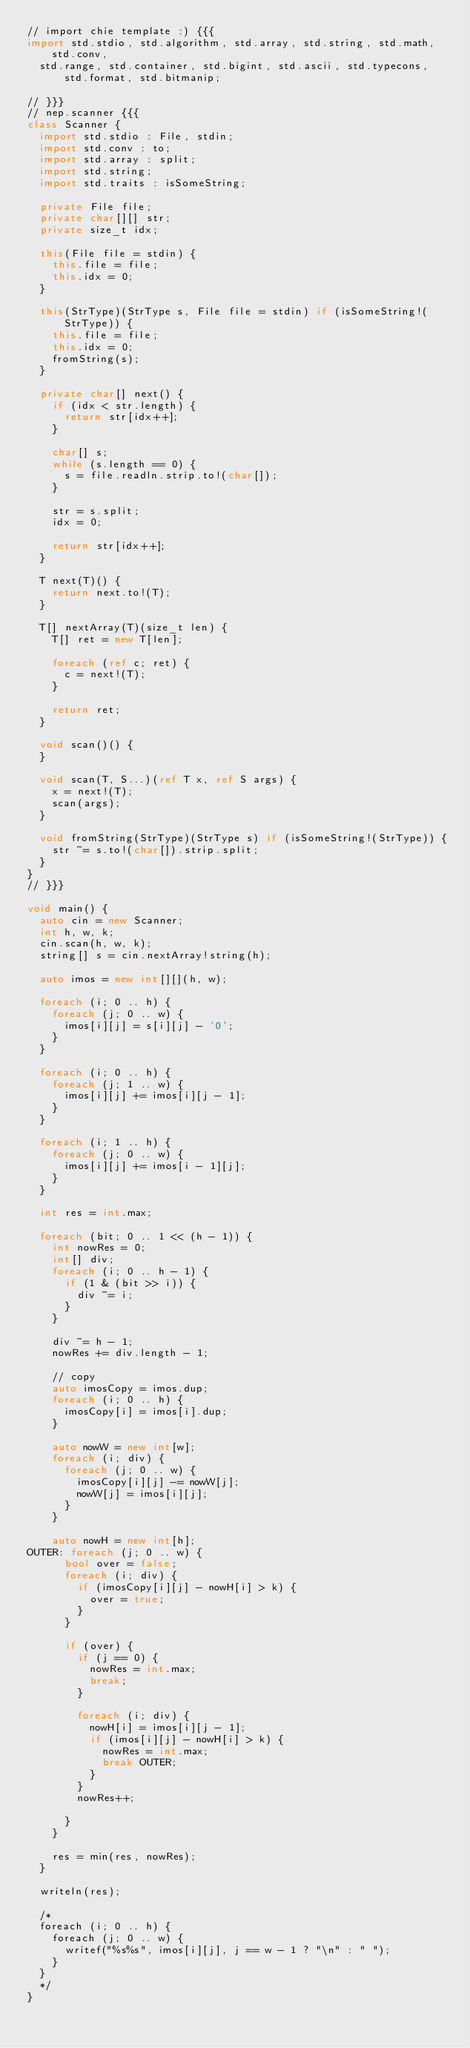<code> <loc_0><loc_0><loc_500><loc_500><_D_>// import chie template :) {{{
import std.stdio, std.algorithm, std.array, std.string, std.math, std.conv,
  std.range, std.container, std.bigint, std.ascii, std.typecons, std.format, std.bitmanip;

// }}}
// nep.scanner {{{
class Scanner {
  import std.stdio : File, stdin;
  import std.conv : to;
  import std.array : split;
  import std.string;
  import std.traits : isSomeString;

  private File file;
  private char[][] str;
  private size_t idx;

  this(File file = stdin) {
    this.file = file;
    this.idx = 0;
  }

  this(StrType)(StrType s, File file = stdin) if (isSomeString!(StrType)) {
    this.file = file;
    this.idx = 0;
    fromString(s);
  }

  private char[] next() {
    if (idx < str.length) {
      return str[idx++];
    }

    char[] s;
    while (s.length == 0) {
      s = file.readln.strip.to!(char[]);
    }

    str = s.split;
    idx = 0;

    return str[idx++];
  }

  T next(T)() {
    return next.to!(T);
  }

  T[] nextArray(T)(size_t len) {
    T[] ret = new T[len];

    foreach (ref c; ret) {
      c = next!(T);
    }

    return ret;
  }

  void scan()() {
  }

  void scan(T, S...)(ref T x, ref S args) {
    x = next!(T);
    scan(args);
  }

  void fromString(StrType)(StrType s) if (isSomeString!(StrType)) {
    str ~= s.to!(char[]).strip.split;
  }
}
// }}}

void main() {
  auto cin = new Scanner;
  int h, w, k;
  cin.scan(h, w, k);
  string[] s = cin.nextArray!string(h);

  auto imos = new int[][](h, w);

  foreach (i; 0 .. h) {
    foreach (j; 0 .. w) {
      imos[i][j] = s[i][j] - '0';
    }
  }

  foreach (i; 0 .. h) {
    foreach (j; 1 .. w) {
      imos[i][j] += imos[i][j - 1];
    }
  }

  foreach (i; 1 .. h) {
    foreach (j; 0 .. w) {
      imos[i][j] += imos[i - 1][j];
    }
  }

  int res = int.max;

  foreach (bit; 0 .. 1 << (h - 1)) {
    int nowRes = 0;
    int[] div;
    foreach (i; 0 .. h - 1) {
      if (1 & (bit >> i)) {
        div ~= i;
      }
    }

    div ~= h - 1;
    nowRes += div.length - 1;

    // copy
    auto imosCopy = imos.dup;
    foreach (i; 0 .. h) {
      imosCopy[i] = imos[i].dup;
    }

    auto nowW = new int[w];
    foreach (i; div) {
      foreach (j; 0 .. w) {
        imosCopy[i][j] -= nowW[j];
        nowW[j] = imos[i][j];
      }
    }

    auto nowH = new int[h];
OUTER: foreach (j; 0 .. w) {
      bool over = false;
      foreach (i; div) {
        if (imosCopy[i][j] - nowH[i] > k) {
          over = true;
        }
      }

      if (over) {
        if (j == 0) {
          nowRes = int.max;
          break;
        }

        foreach (i; div) {
          nowH[i] = imos[i][j - 1];
          if (imos[i][j] - nowH[i] > k) {
            nowRes = int.max;
            break OUTER;
          }
        }
        nowRes++;

      }
    }

    res = min(res, nowRes);
  }

  writeln(res);

  /*
  foreach (i; 0 .. h) {
    foreach (j; 0 .. w) {
      writef("%s%s", imos[i][j], j == w - 1 ? "\n" : " ");
    }
  }
  */
}
</code> 